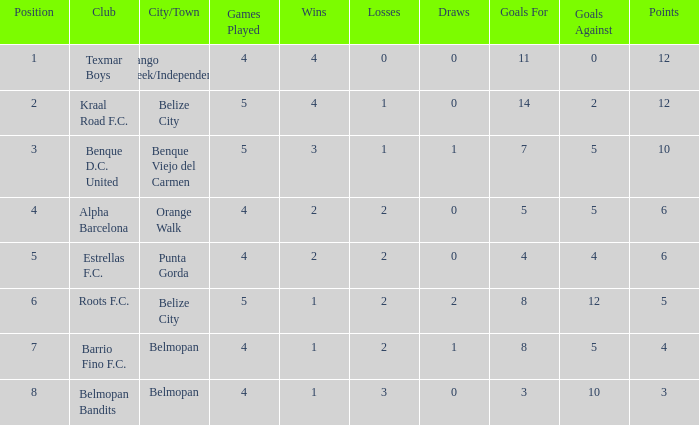What's the w-l-d with position being 1 4-0-0. 